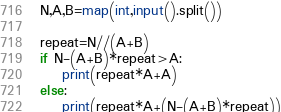Convert code to text. <code><loc_0><loc_0><loc_500><loc_500><_Python_>N,A,B=map(int,input().split())

repeat=N//(A+B)
if N-(A+B)*repeat>A:
    print(repeat*A+A)
else:
    print(repeat*A+(N-(A+B)*repeat))</code> 